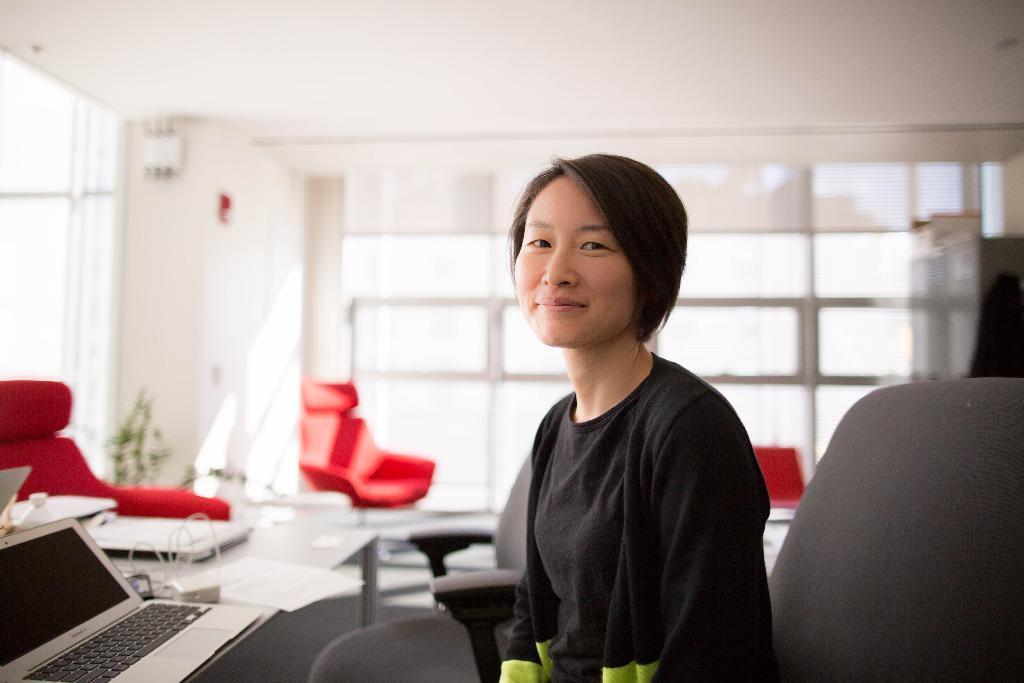Could you give a brief overview of what you see in this image? The image is inside the room. In the image there is a woman sitting on chair in front of a table. On table we can see a laptop,wires and some papers, in background there is a white color wall and windows which are closed and there is a roof on top. 